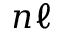Convert formula to latex. <formula><loc_0><loc_0><loc_500><loc_500>n \ell</formula> 